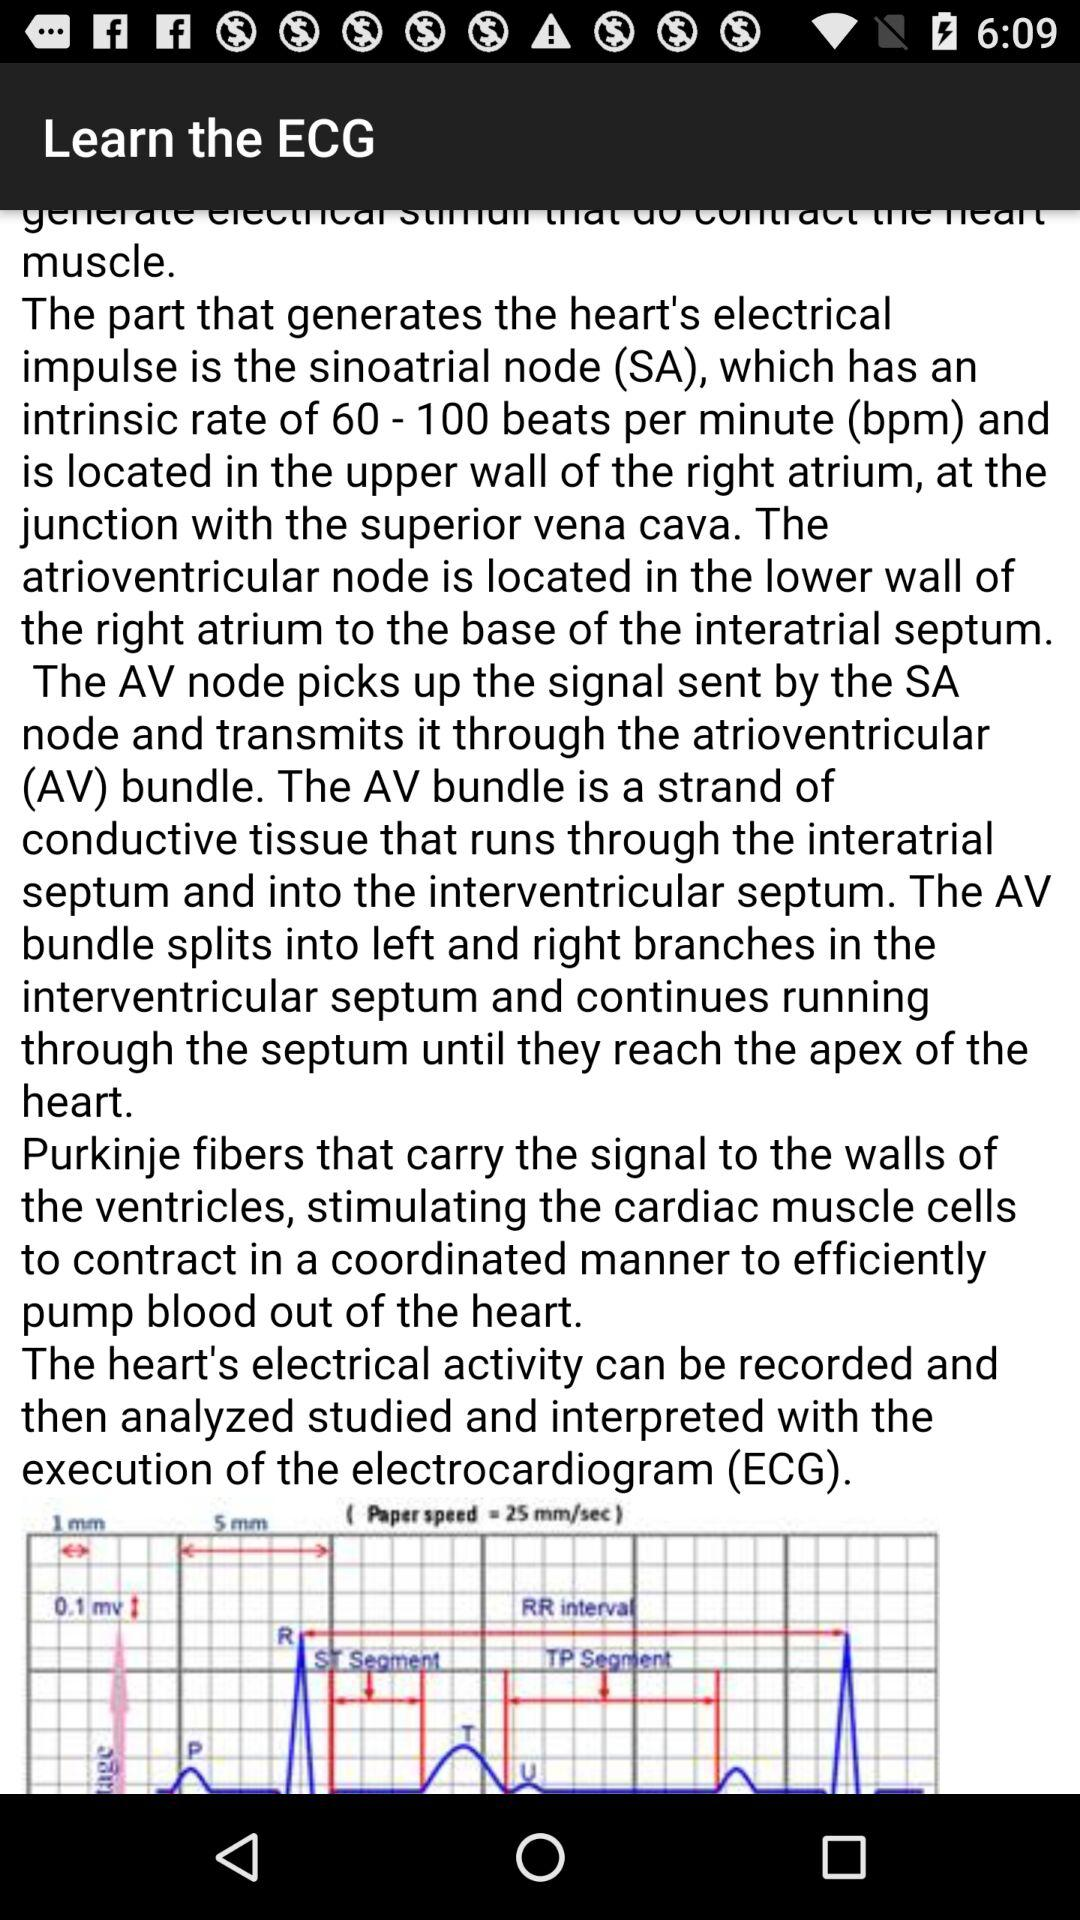What is the application name? The application name is "ECG practical demo". 